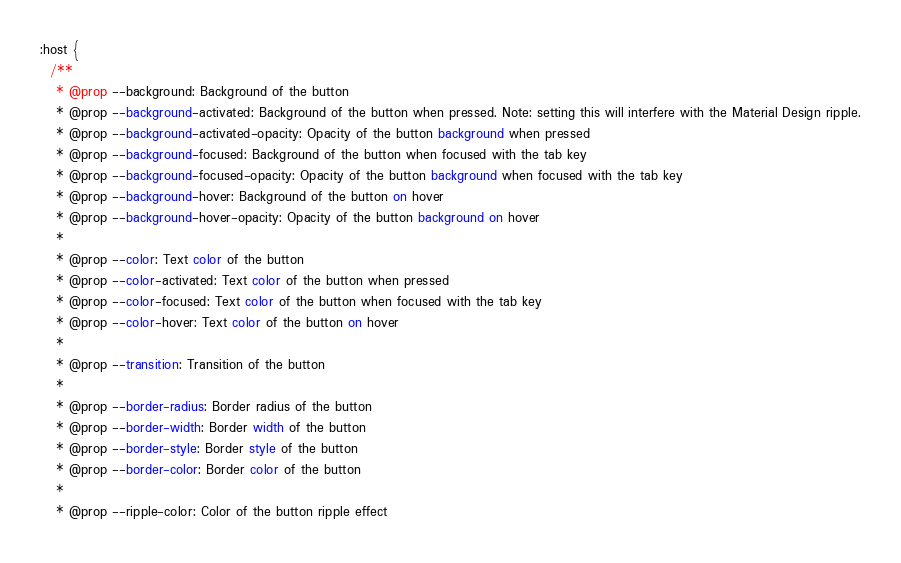Convert code to text. <code><loc_0><loc_0><loc_500><loc_500><_CSS_>:host {
  /**
   * @prop --background: Background of the button
   * @prop --background-activated: Background of the button when pressed. Note: setting this will interfere with the Material Design ripple.
   * @prop --background-activated-opacity: Opacity of the button background when pressed
   * @prop --background-focused: Background of the button when focused with the tab key
   * @prop --background-focused-opacity: Opacity of the button background when focused with the tab key
   * @prop --background-hover: Background of the button on hover
   * @prop --background-hover-opacity: Opacity of the button background on hover
   *
   * @prop --color: Text color of the button
   * @prop --color-activated: Text color of the button when pressed
   * @prop --color-focused: Text color of the button when focused with the tab key
   * @prop --color-hover: Text color of the button on hover
   *
   * @prop --transition: Transition of the button
   *
   * @prop --border-radius: Border radius of the button
   * @prop --border-width: Border width of the button
   * @prop --border-style: Border style of the button
   * @prop --border-color: Border color of the button
   *
   * @prop --ripple-color: Color of the button ripple effect</code> 